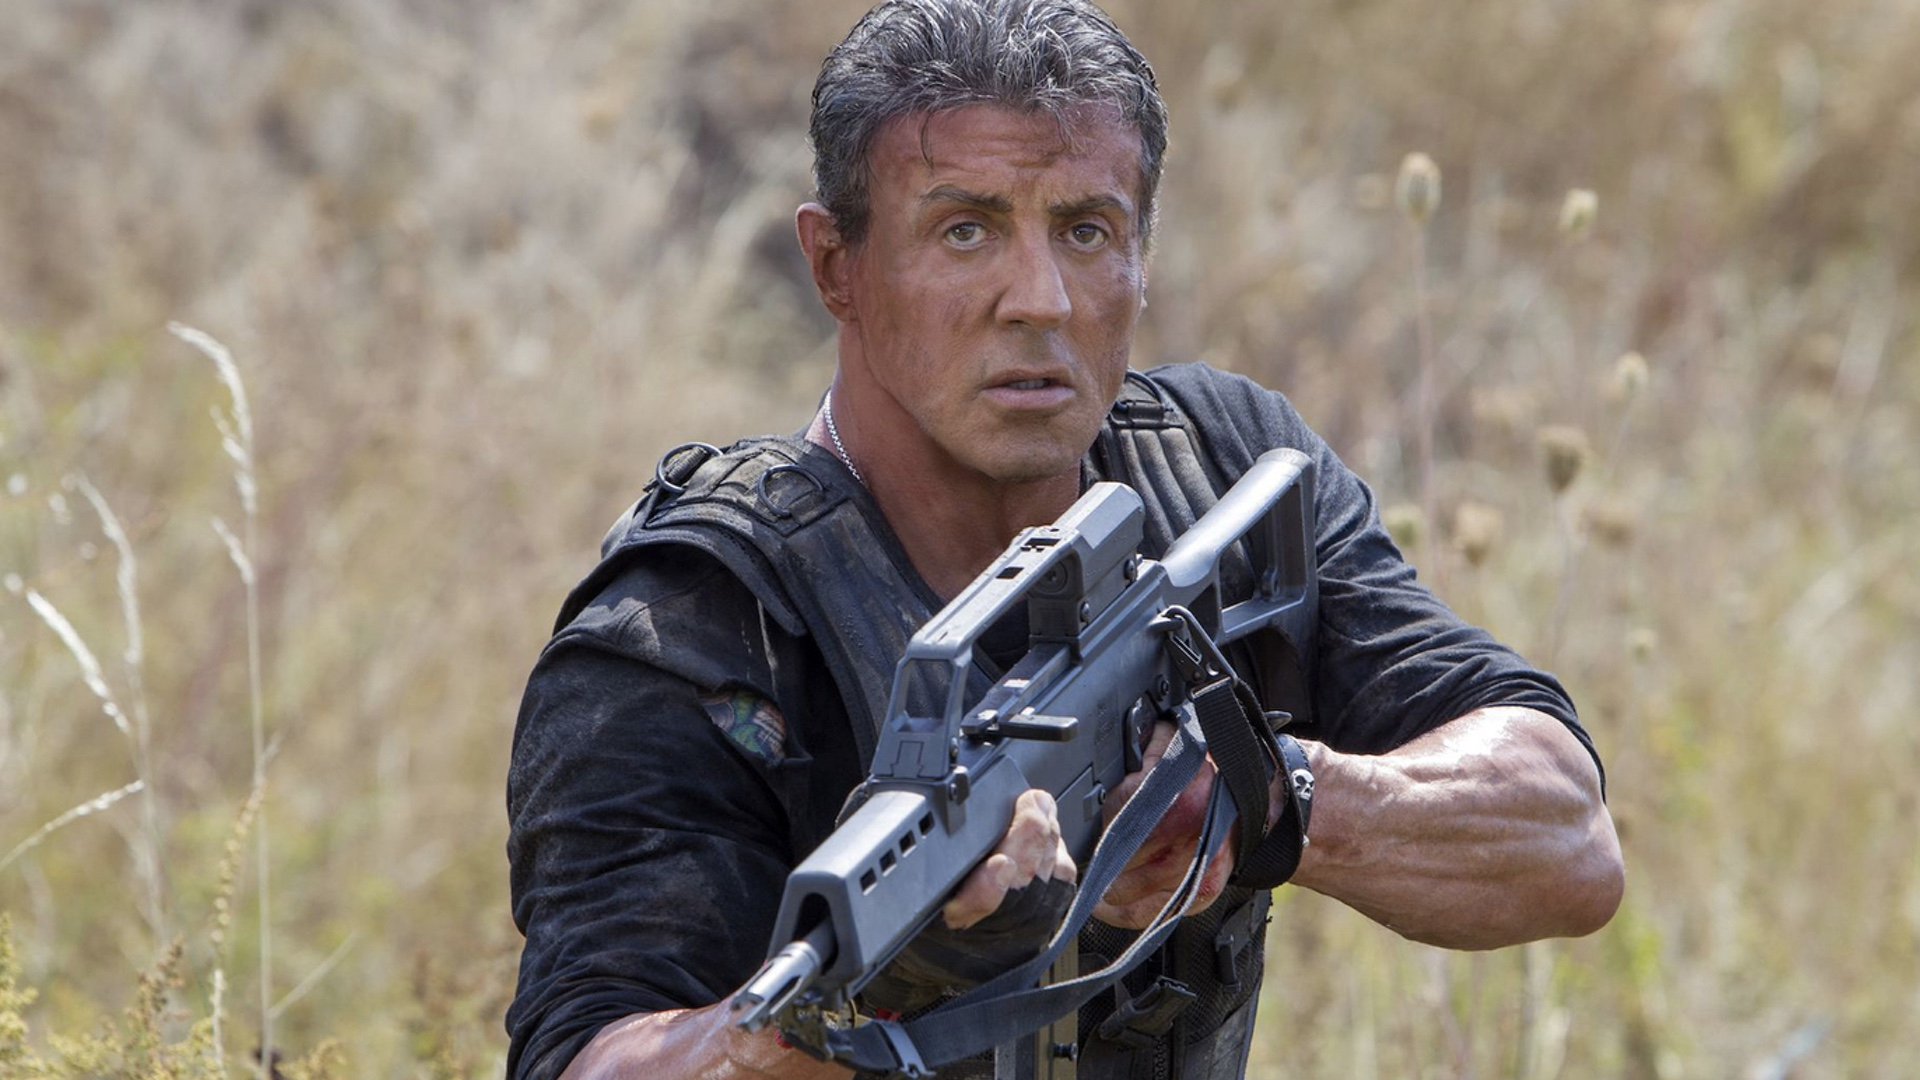What do you think Rambo is preparing for in this scene? Rambo appears to be bracing himself for a hostile encounter. His focused expression and firm grip on his firearm suggest that he is anticipating an imminent threat. The wild, untamed environment hints at a scenario where Rambo could potentially face an ambush, requiring him to rely on his survival instincts and combat skills. 